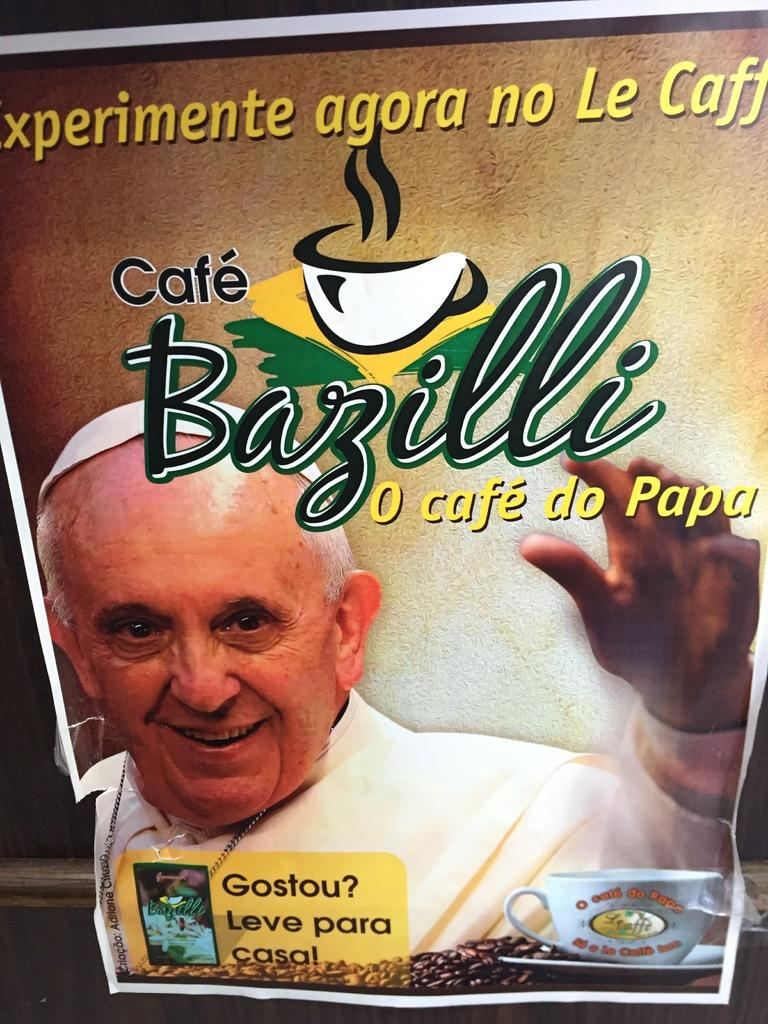What is hanging on a rod in the image? There is a poster on a rod in the image. What is depicted in the poster? The poster contains a picture of a person smiling. Are there any objects related to coffee in the poster? Yes, there is a cup, a saucer, and coffee beans in the poster. Is there any text in the poster? Yes, there is text in the poster. How many trucks are visible in the poster? There are no trucks visible in the poster; it features a person smiling, coffee-related objects, and text. Is there a bat flying in the poster? There is no bat present in the poster; it only contains a person smiling, coffee-related objects, and text. 